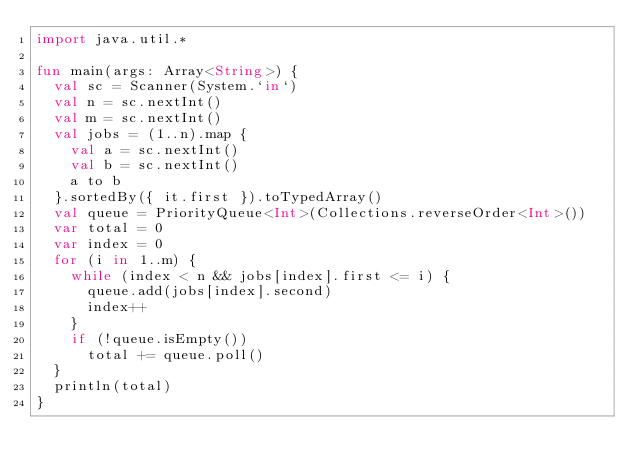Convert code to text. <code><loc_0><loc_0><loc_500><loc_500><_Kotlin_>import java.util.*

fun main(args: Array<String>) {
  val sc = Scanner(System.`in`)
  val n = sc.nextInt()
  val m = sc.nextInt()
  val jobs = (1..n).map {
    val a = sc.nextInt()
    val b = sc.nextInt()
    a to b
  }.sortedBy({ it.first }).toTypedArray()
  val queue = PriorityQueue<Int>(Collections.reverseOrder<Int>())
  var total = 0
  var index = 0
  for (i in 1..m) {
    while (index < n && jobs[index].first <= i) {
      queue.add(jobs[index].second)
      index++
    }
    if (!queue.isEmpty())
      total += queue.poll()
  }
  println(total)
}
</code> 